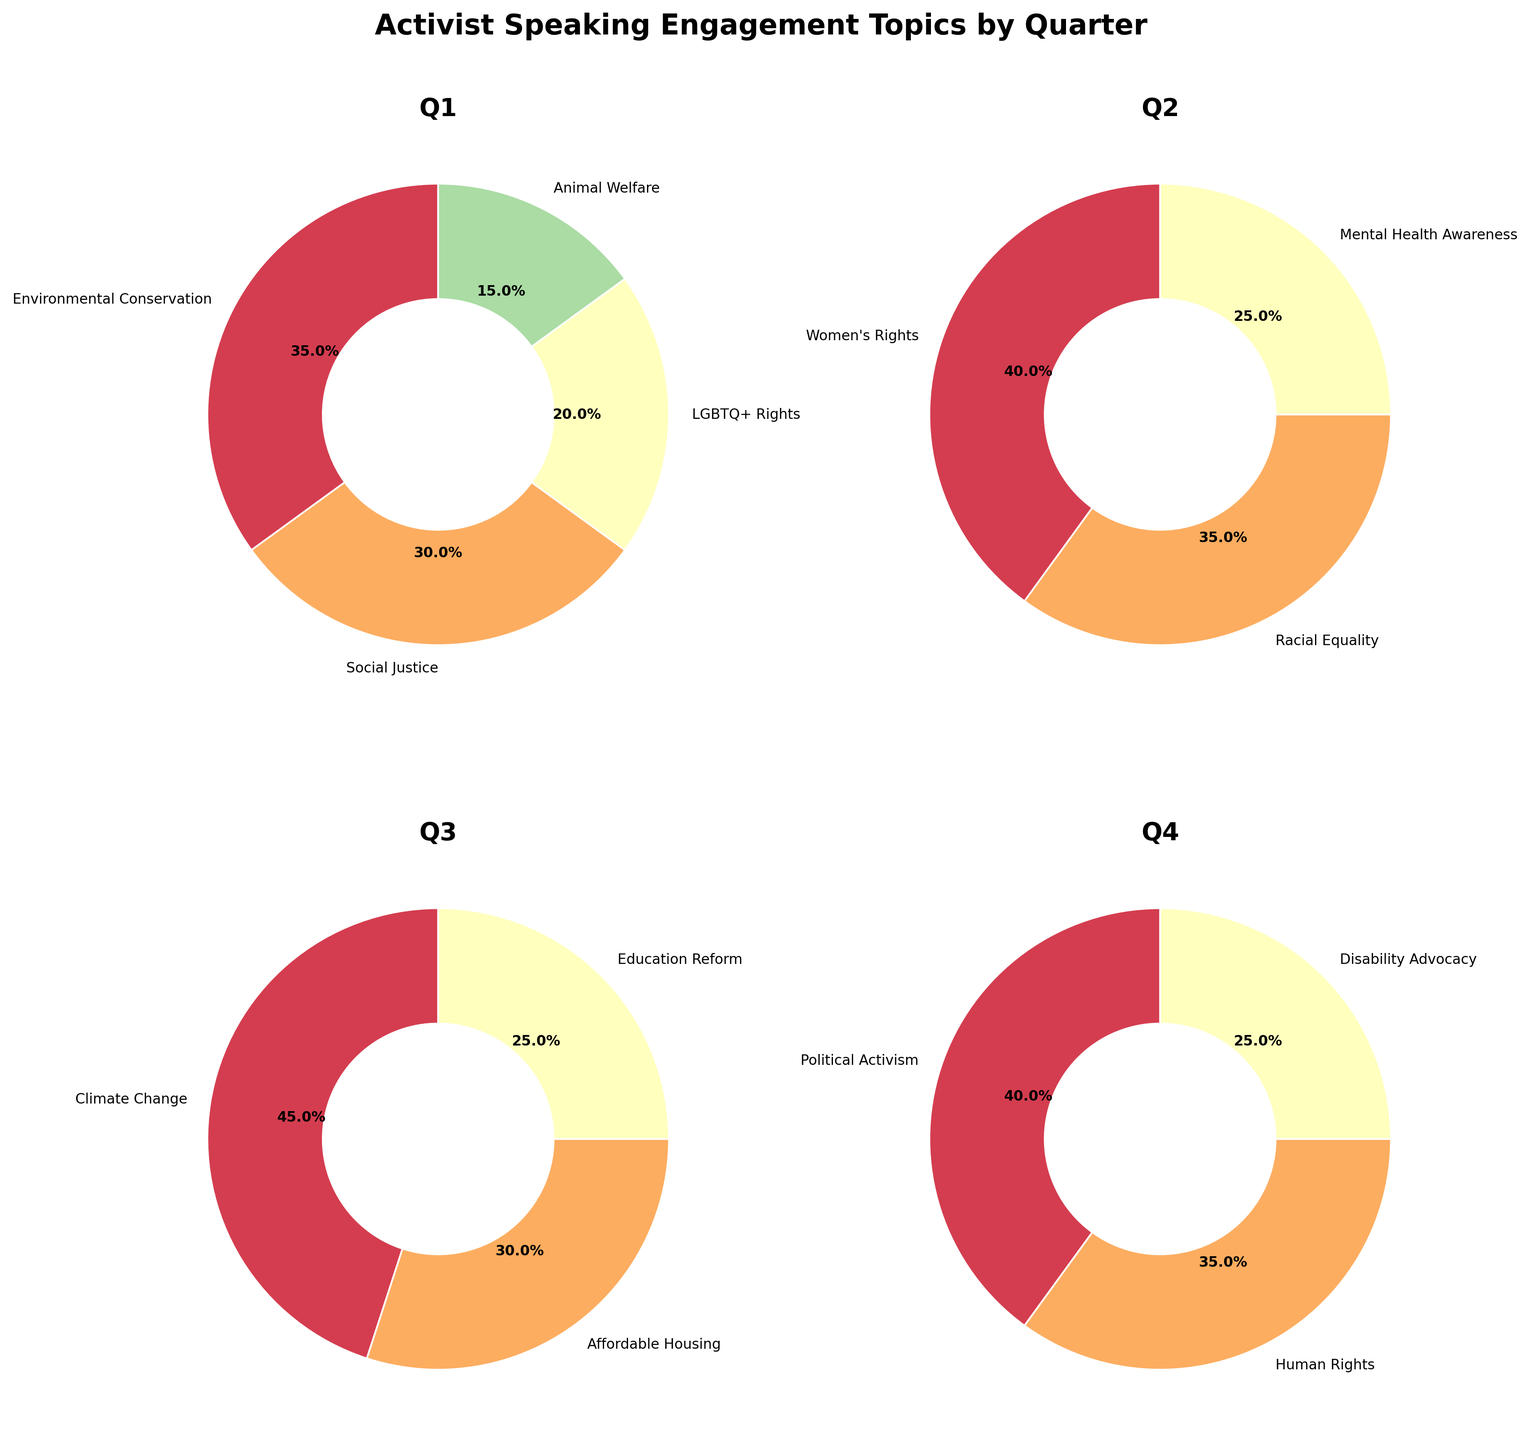What is the title of the figure? The title is displayed at the top of the figure in bold font. Reading this text directly from the visual element of the figure, we get "Activist Speaking Engagement Topics by Quarter".
Answer: Activist Speaking Engagement Topics by Quarter How many different topics are covered in the first quarter (Q1)? Each pie chart represents a different quarter, and the segments show different topics. For Q1, the segments are labeled: Environmental Conservation, Social Justice, LGBTQ+ Rights, and Animal Welfare. Counting these labels gives four topics.
Answer: Four What is the topic with the highest percentage in Q2? Each pie chart shows segments with their respective percentages. In the Q2 pie chart, the segment with the highest percentage is labeled Women's Rights with 40%.
Answer: Women's Rights Which quarter had Climate Change as one of its topics? The topic “Climate Change” appears as one of the labels only in Quarter 3. Checking the pie charts, we identify the label under Q3.
Answer: Q3 What is the total percentage for Social Justice and LGBTQ+ Rights in Q1? To calculate the total percentage, we sum the individual percentages. In Q1, Social Justice is 30% and LGBTQ+ Rights is 20%. Adding these gives 30% + 20% = 50%.
Answer: 50% What is the difference in percentage between Climate Change in Q3 and Mental Health Awareness in Q2? The pie chart for Q3 shows Climate Change at 45%. The pie chart for Q2 shows Mental Health Awareness at 25%. The difference is calculated as 45% - 25% = 20%.
Answer: 20% Compare the highest percentage topics in Q4 and Q2. Which one is larger? The highest percentage topic for Q4 is Political Activism at 40%. For Q2, it’s Women's Rights at 40%. Both are equal in value.
Answer: Equal What percentage of the topics in Q4 are related to human rights? Checking the percentage labels for Q4, we see Human Rights at 35%. Since this is the only segment explicitly labeled as related to human rights, the percentage is 35%.
Answer: 35% Are there any quarters where the topics have an equal percentage distribution? Reviewing each pie chart, we check if there is any chart where all segments are equal. None of the quarters show an equal distribution across all topics; varying percentages are observed in each chart.
Answer: No What is the least represented topic in Q3? The pie chart for Q3 has segments labeled with percentages. The lowest percentage label is 25%, which corresponds to the topic Education Reform.
Answer: Education Reform 